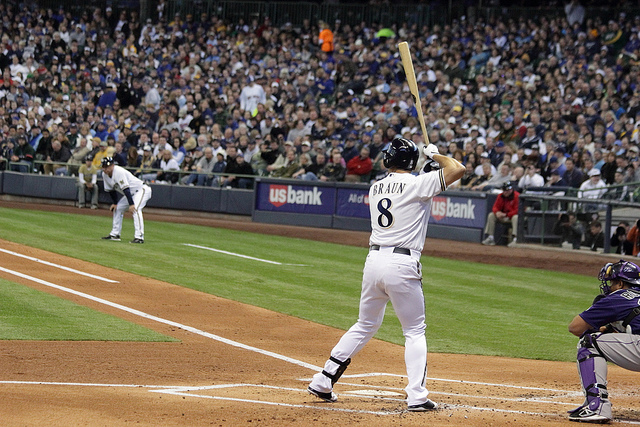Is there any indication of which teams are playing? Yes, based on the uniforms seen in the image, one team is identifiable due to the distinctive lettering on the batter's jersey. However, without clearer logos or team names, the specific teams cannot be determined from this angle.  Can you tell anything about the strategy being used in this moment of the game? It's difficult to determine the exact strategy without more context, but the pitcher is in a wind-up, indicating that there's likely no immediate threat of base runners stealing. The batter appears focused and ready, suggesting he might be waiting for a good pitch to hit aggressively. 